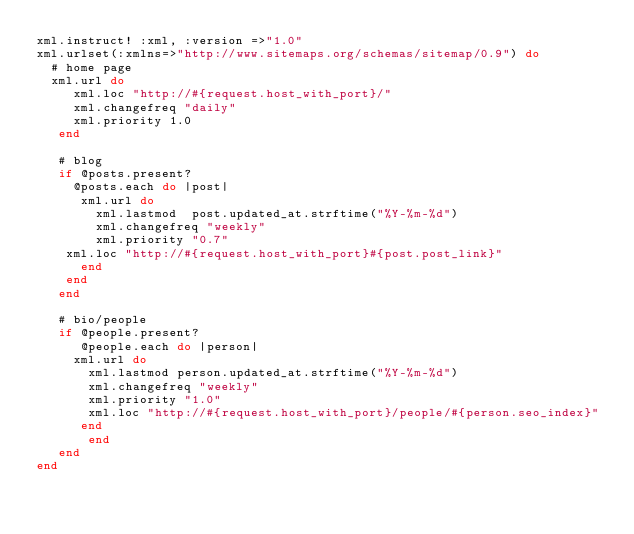Convert code to text. <code><loc_0><loc_0><loc_500><loc_500><_Ruby_>xml.instruct! :xml, :version =>"1.0"
xml.urlset(:xmlns=>"http://www.sitemaps.org/schemas/sitemap/0.9") do
  # home page
  xml.url do
     xml.loc "http://#{request.host_with_port}/"
     xml.changefreq "daily"
     xml.priority 1.0
   end
   
   # blog
   if @posts.present?
     @posts.each do |post|
      xml.url do
        xml.lastmod  post.updated_at.strftime("%Y-%m-%d")
        xml.changefreq "weekly"
        xml.priority "0.7"
	xml.loc "http://#{request.host_with_port}#{post.post_link}"
      end
    end
   end
   
   # bio/people
   if @people.present?
      @people.each do |person|
	 xml.url do
	   xml.lastmod person.updated_at.strftime("%Y-%m-%d")
	   xml.changefreq "weekly"
	   xml.priority "1.0"
	   xml.loc "http://#{request.host_with_port}/people/#{person.seo_index}"
	  end
       end
   end
end
</code> 